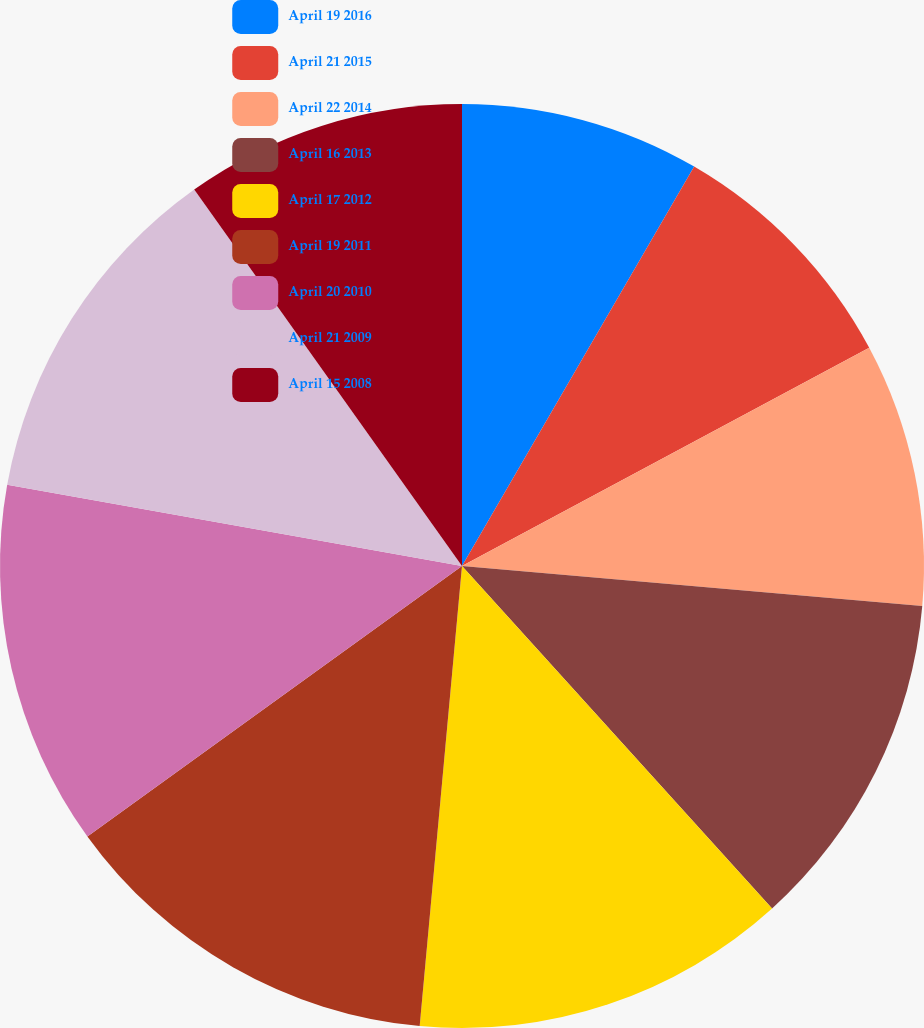Convert chart. <chart><loc_0><loc_0><loc_500><loc_500><pie_chart><fcel>April 19 2016<fcel>April 21 2015<fcel>April 22 2014<fcel>April 16 2013<fcel>April 17 2012<fcel>April 19 2011<fcel>April 20 2010<fcel>April 21 2009<fcel>April 15 2008<nl><fcel>8.38%<fcel>8.79%<fcel>9.21%<fcel>11.91%<fcel>13.17%<fcel>13.59%<fcel>12.76%<fcel>12.35%<fcel>9.84%<nl></chart> 